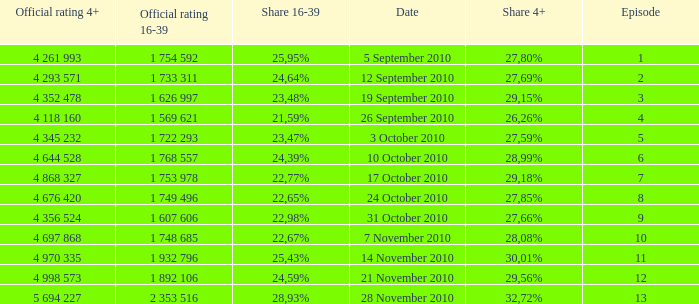What is the official 4+ rating of the episode with a 16-39 share of 24,59%? 4 998 573. 